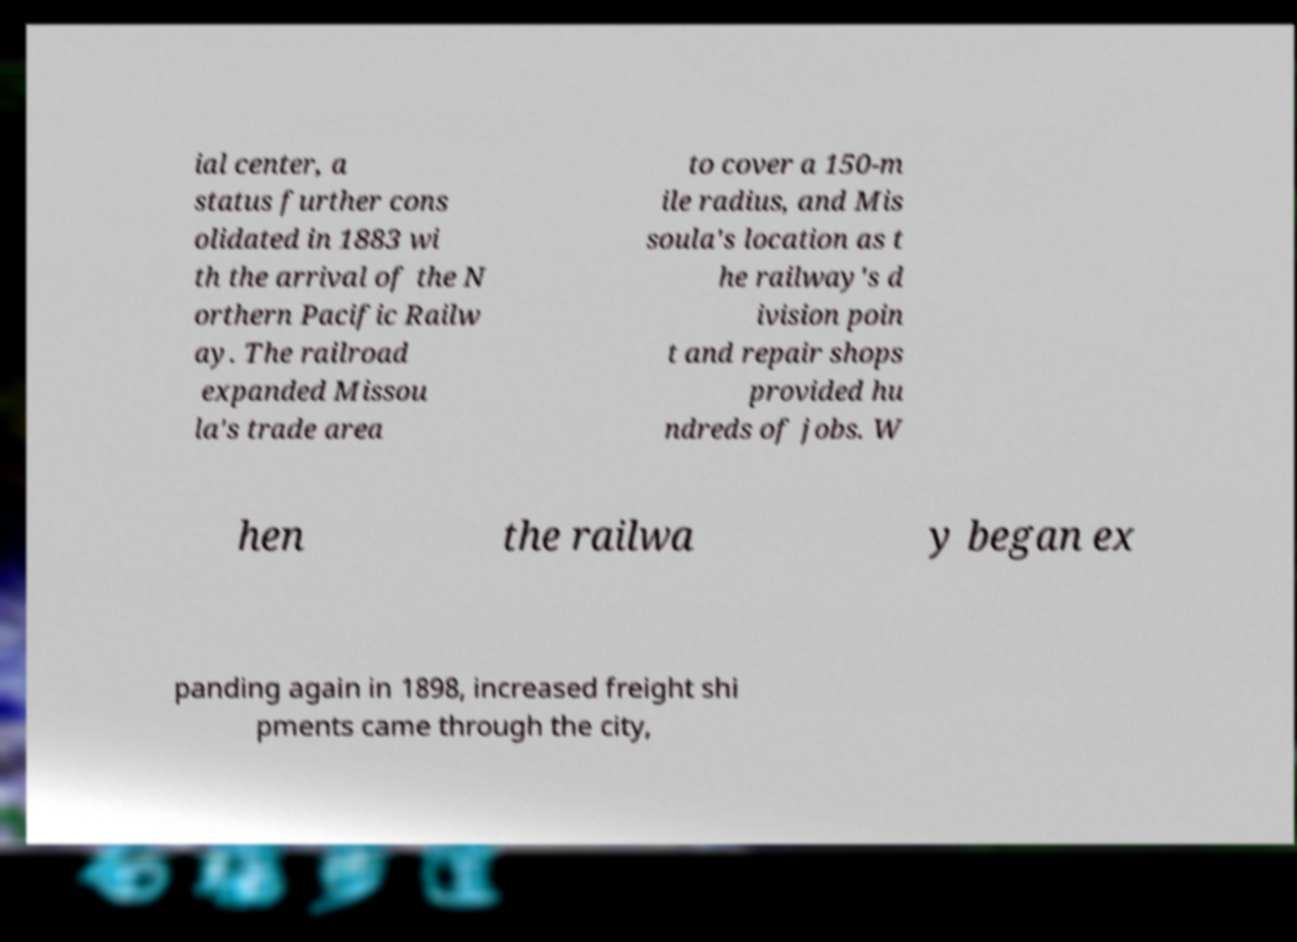Can you read and provide the text displayed in the image?This photo seems to have some interesting text. Can you extract and type it out for me? ial center, a status further cons olidated in 1883 wi th the arrival of the N orthern Pacific Railw ay. The railroad expanded Missou la's trade area to cover a 150-m ile radius, and Mis soula's location as t he railway's d ivision poin t and repair shops provided hu ndreds of jobs. W hen the railwa y began ex panding again in 1898, increased freight shi pments came through the city, 